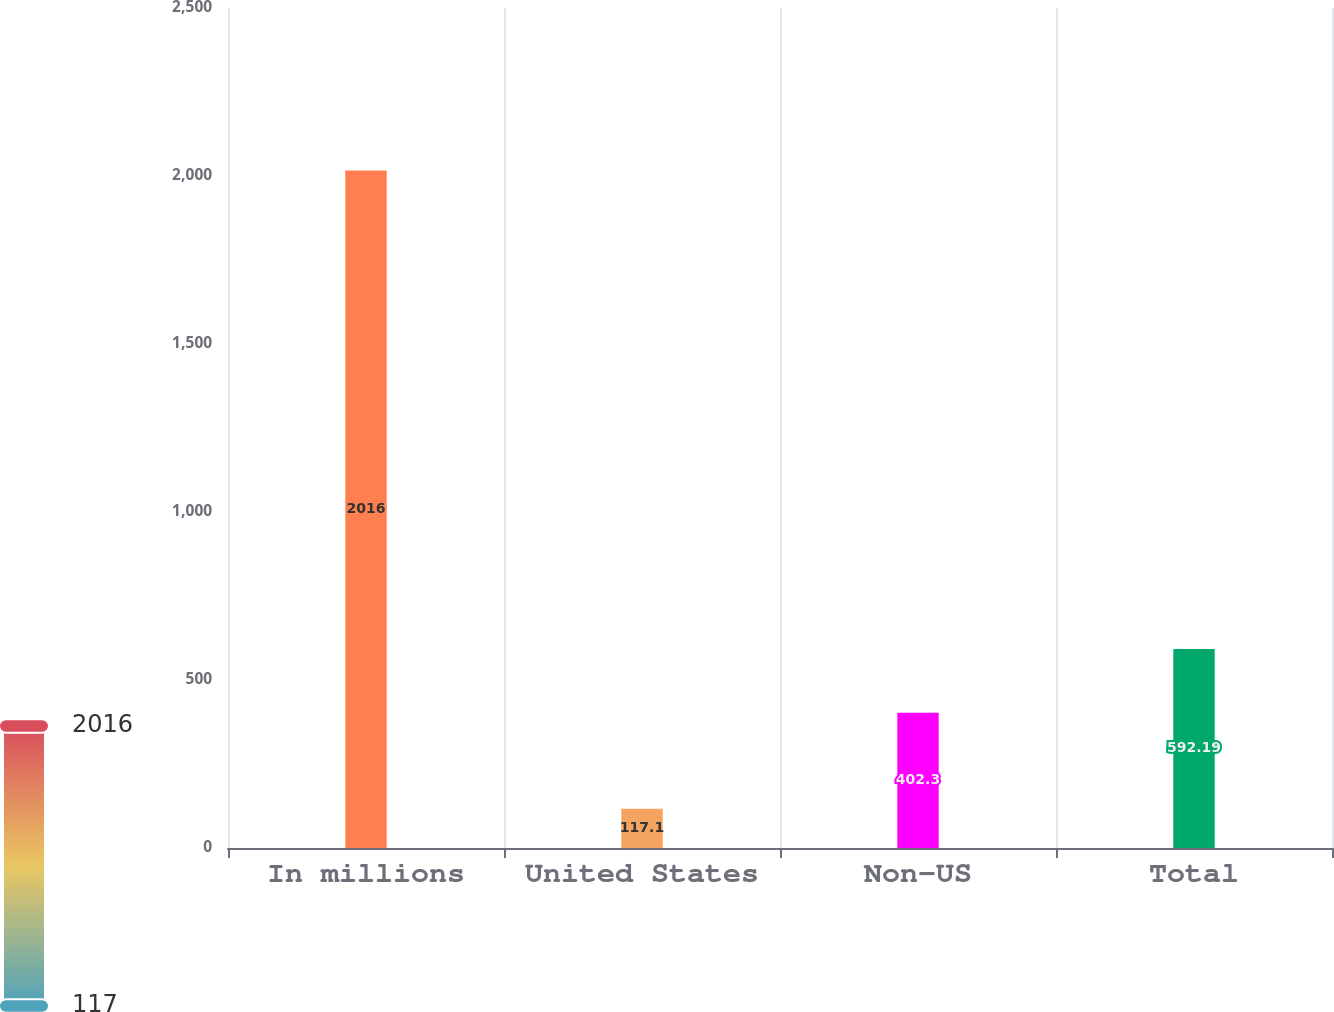Convert chart to OTSL. <chart><loc_0><loc_0><loc_500><loc_500><bar_chart><fcel>In millions<fcel>United States<fcel>Non-US<fcel>Total<nl><fcel>2016<fcel>117.1<fcel>402.3<fcel>592.19<nl></chart> 